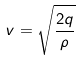<formula> <loc_0><loc_0><loc_500><loc_500>v = \sqrt { \frac { 2 q } { \rho } }</formula> 